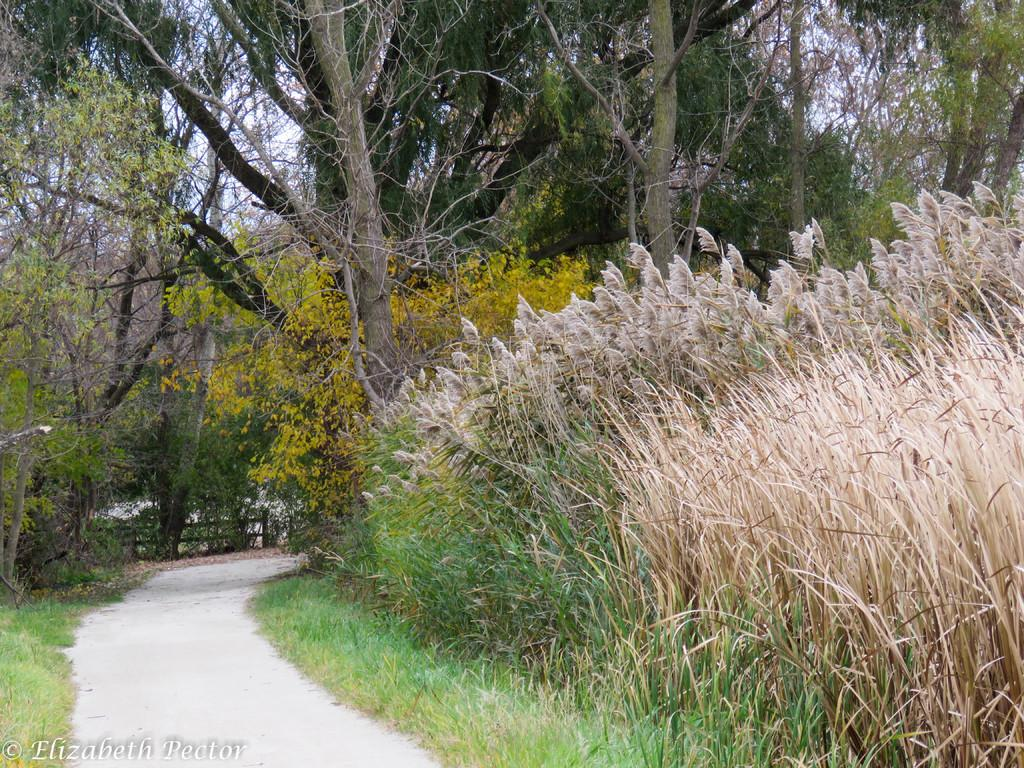What type of vegetation is visible on the ground in the image? There is grass on the ground in the image. What other types of vegetation can be seen in the image? There are trees and plants visible in the image. What type of lip can be seen on the trees in the image? There are no lips present on the trees in the image. Are there any flowers visible in the image? The provided facts do not mention flowers, so we cannot definitively answer whether there are any flowers visible in the image. Can you see any icicles hanging from the trees in the image? There are no icicles present in the image. 